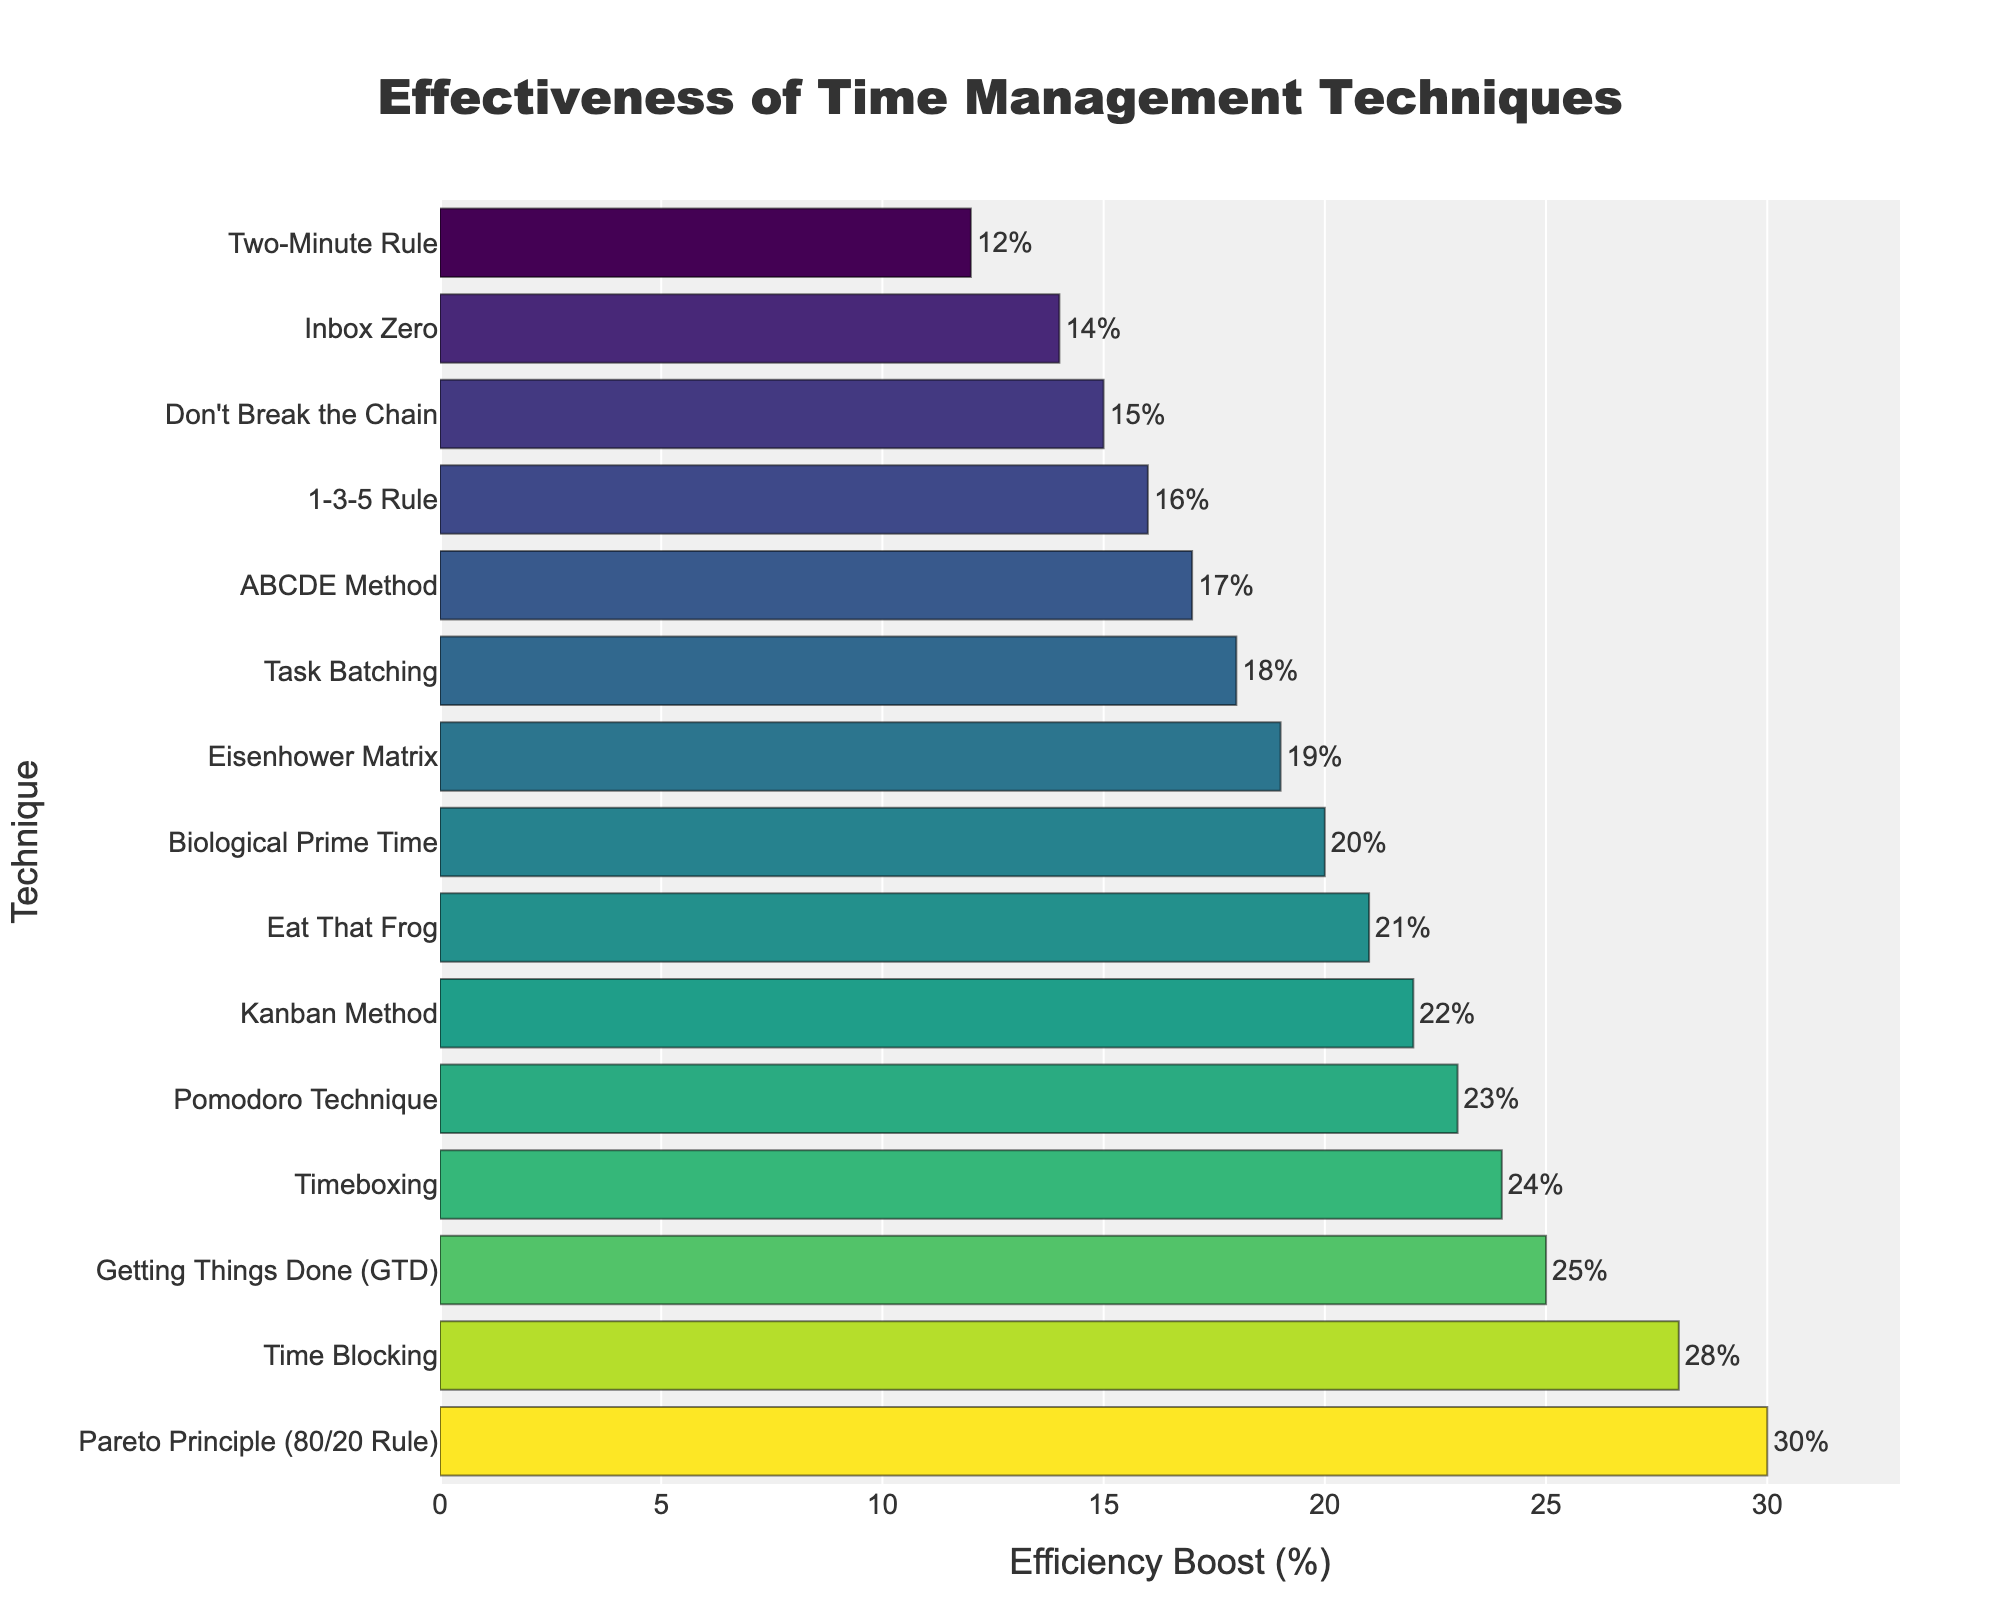What's the most effective time management technique in boosting workplace efficiency? To identify the most effective technique, we look for the highest bar in the bar chart. The Pareto Principle (80/20 Rule) has the highest value of 30%.
Answer: Pareto Principle (80/20 Rule) What's the efficiency boost percentage difference between the Pomodoro Technique and the GTD (Getting Things Done)? First, find the efficiency boost of both techniques: Pomodoro Technique is 23% and GTD is 25%. Then, subtract the smaller value from the larger value: 25% - 23% = 2%.
Answer: 2% How many techniques have an efficiency boost greater than 20%? Count the bars with values greater than 20%: Pomodoro Technique (23%), Time Blocking (28%), GTD (25%), Pareto Principle (30%), Timeboxing (24%), and Kanban Method (22%). This totals to 6 techniques.
Answer: 6 Which technique has a similar efficiency boost percentage to 'Eat That Frog' within a margin of 1%? The 'Eat That Frog' technique has an efficiency boost of 21%. Checking values within 20% to 22%, the Kanban Method has an efficiency boost of 22%, which is within this range.
Answer: Kanban Method What is the average efficiency boost of the top three techniques? Identify the top three techniques: Pareto Principle (30%), Time Blocking (28%), and GTD (25%). Sum these values and divide by 3: (30 + 28 + 25) / 3 = 27.67%.
Answer: 27.67% What is the combined efficiency boost of the least effective three techniques? Identify the three techniques with the lowest efficiency boost: Two-Minute Rule (12%), Inbox Zero (14%), and Don't Break the Chain (15%). Sum these values: 12% + 14% + 15% = 41%.
Answer: 41% What is noticeably different about the bar representing the Pareto Principle compared to others? The bar representing the Pareto Principle is the longest, indicating it has the highest efficiency boost percentage (30%).
Answer: It is the longest bar How much more efficient is Time Blocking compared to the ABCDE Method? Find the efficiency boost for both: Time Blocking (28%) and the ABCDE Method (17%). Subtract the smaller value from the larger value: 28% - 17% = 11%.
Answer: 11% Which techniques have an efficiency boost in the range of 15-20%? Identify the techniques within this range: Eisenhower Matrix (19%), Task Batching (18%), Don't Break the Chain (15%), ABCDE Method (17%), and Biological Prime Time (20%).
Answer: Eisenhower Matrix, Task Batching, Don't Break the Chain, ABCDE Method, Biological Prime Time What is the total efficiency boost of all techniques combined? Sum all the efficiency boost percentages: 23% + 28% + 19% + 25% + 16% + 12% + 21% + 30% + 24% + 18% + 15% + 17% + 20% + 22% + 14% = 304%.
Answer: 304% 